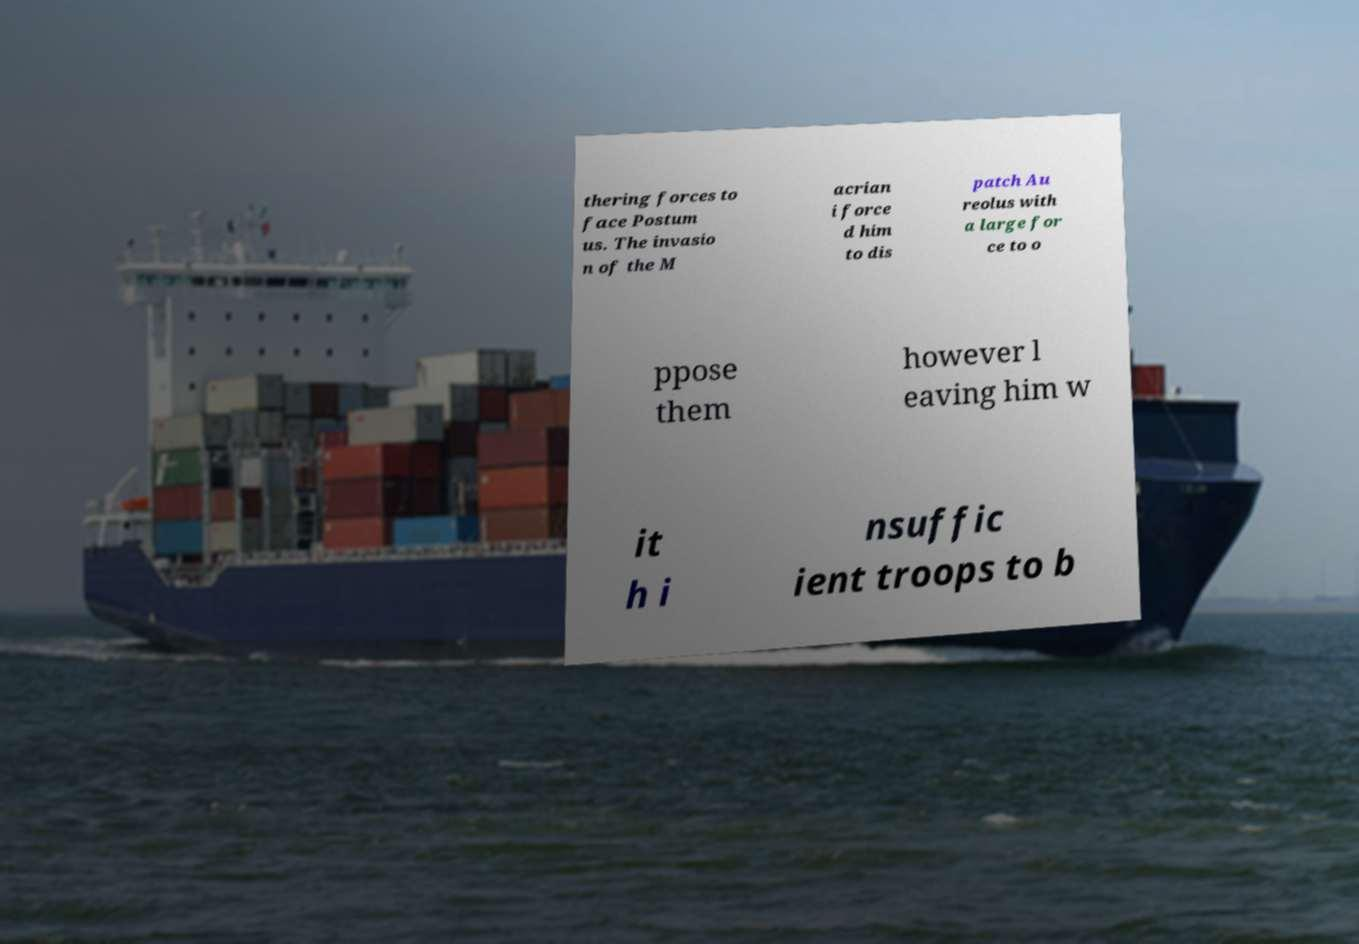Could you assist in decoding the text presented in this image and type it out clearly? thering forces to face Postum us. The invasio n of the M acrian i force d him to dis patch Au reolus with a large for ce to o ppose them however l eaving him w it h i nsuffic ient troops to b 